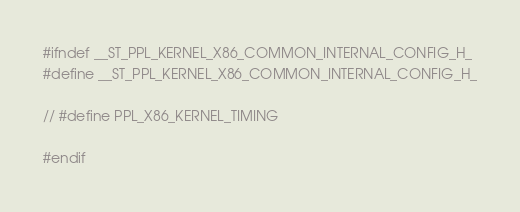<code> <loc_0><loc_0><loc_500><loc_500><_C_>#ifndef __ST_PPL_KERNEL_X86_COMMON_INTERNAL_CONFIG_H_
#define __ST_PPL_KERNEL_X86_COMMON_INTERNAL_CONFIG_H_

// #define PPL_X86_KERNEL_TIMING

#endif
</code> 